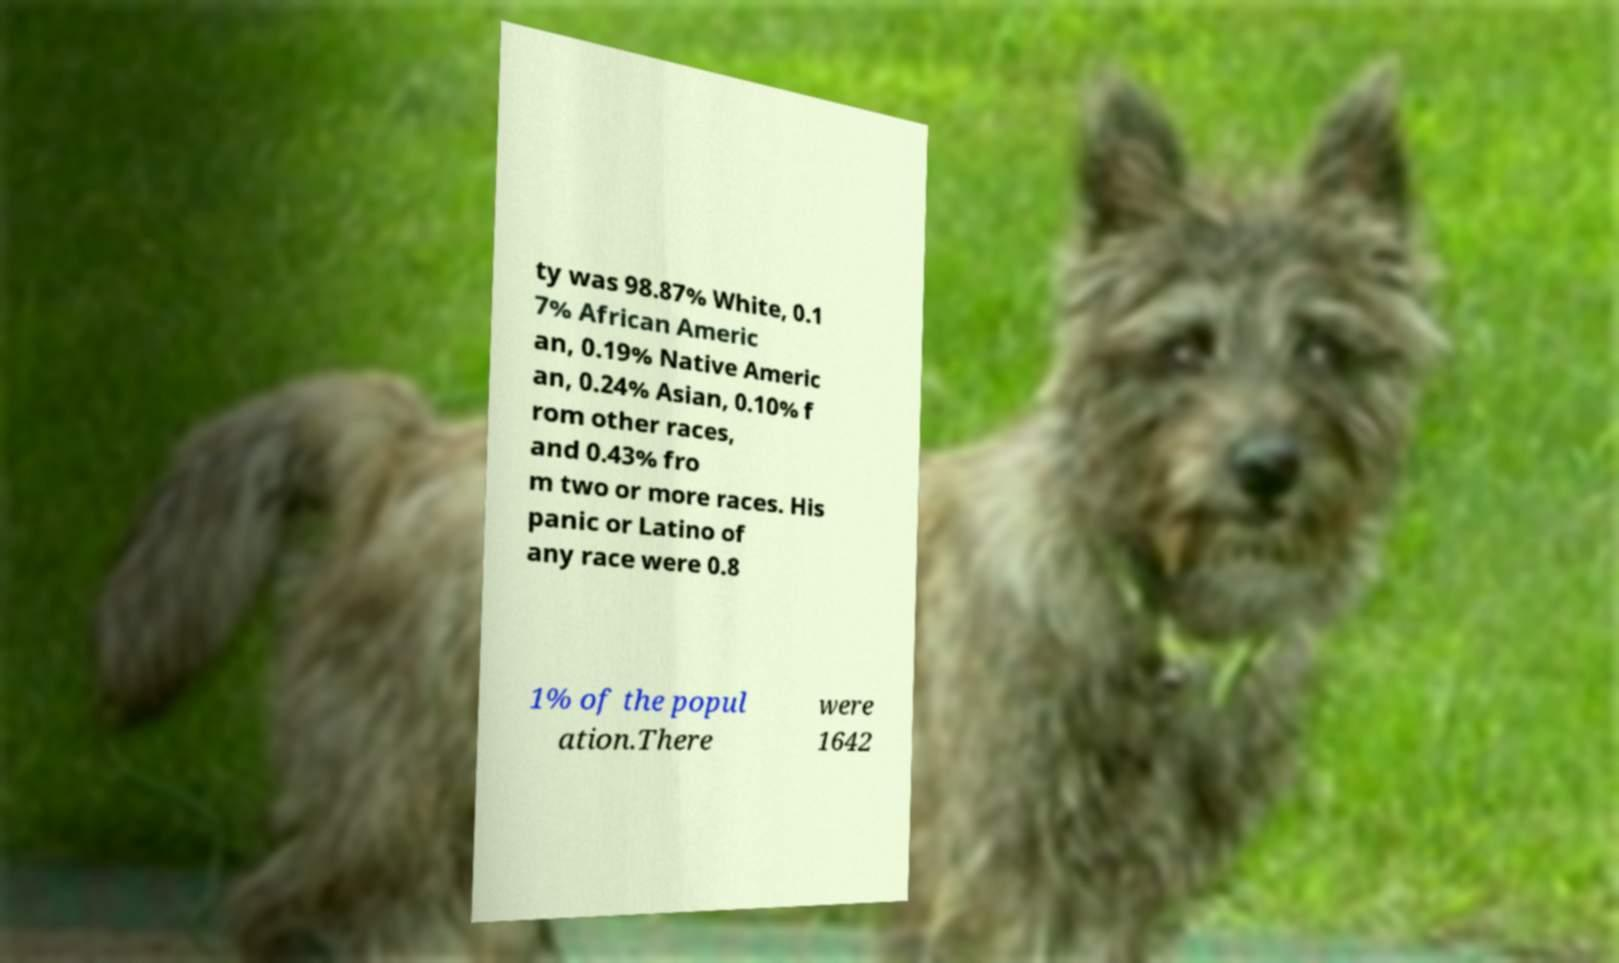I need the written content from this picture converted into text. Can you do that? ty was 98.87% White, 0.1 7% African Americ an, 0.19% Native Americ an, 0.24% Asian, 0.10% f rom other races, and 0.43% fro m two or more races. His panic or Latino of any race were 0.8 1% of the popul ation.There were 1642 